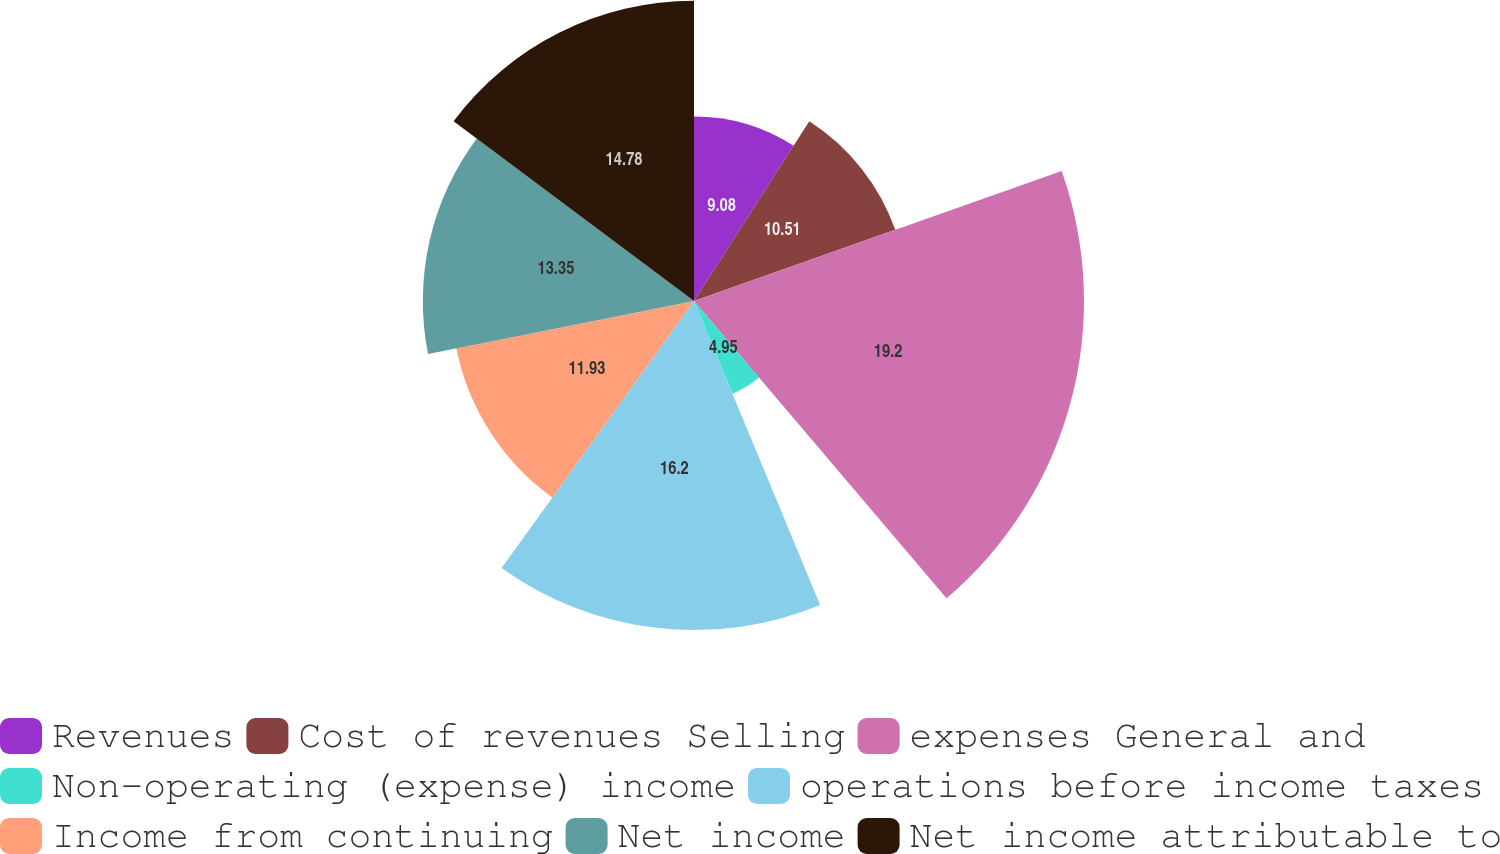<chart> <loc_0><loc_0><loc_500><loc_500><pie_chart><fcel>Revenues<fcel>Cost of revenues Selling<fcel>expenses General and<fcel>Non-operating (expense) income<fcel>operations before income taxes<fcel>Income from continuing<fcel>Net income<fcel>Net income attributable to<nl><fcel>9.08%<fcel>10.51%<fcel>19.2%<fcel>4.95%<fcel>16.2%<fcel>11.93%<fcel>13.35%<fcel>14.78%<nl></chart> 